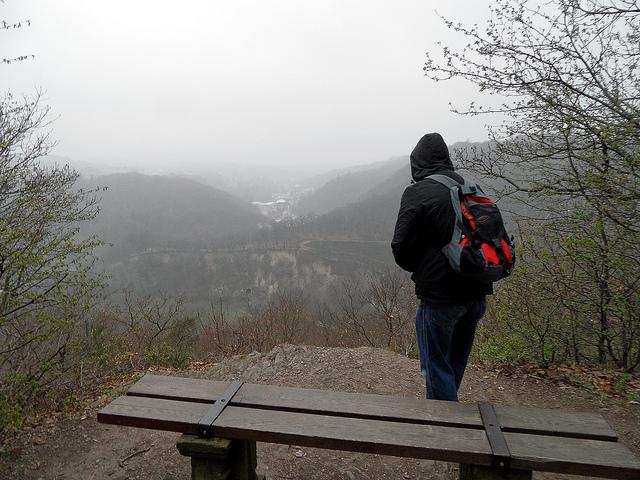What item here can hold the most books? Please explain your reasoning. backpack. Generally school aged people use backpacks, as they hold alot of things easily. 